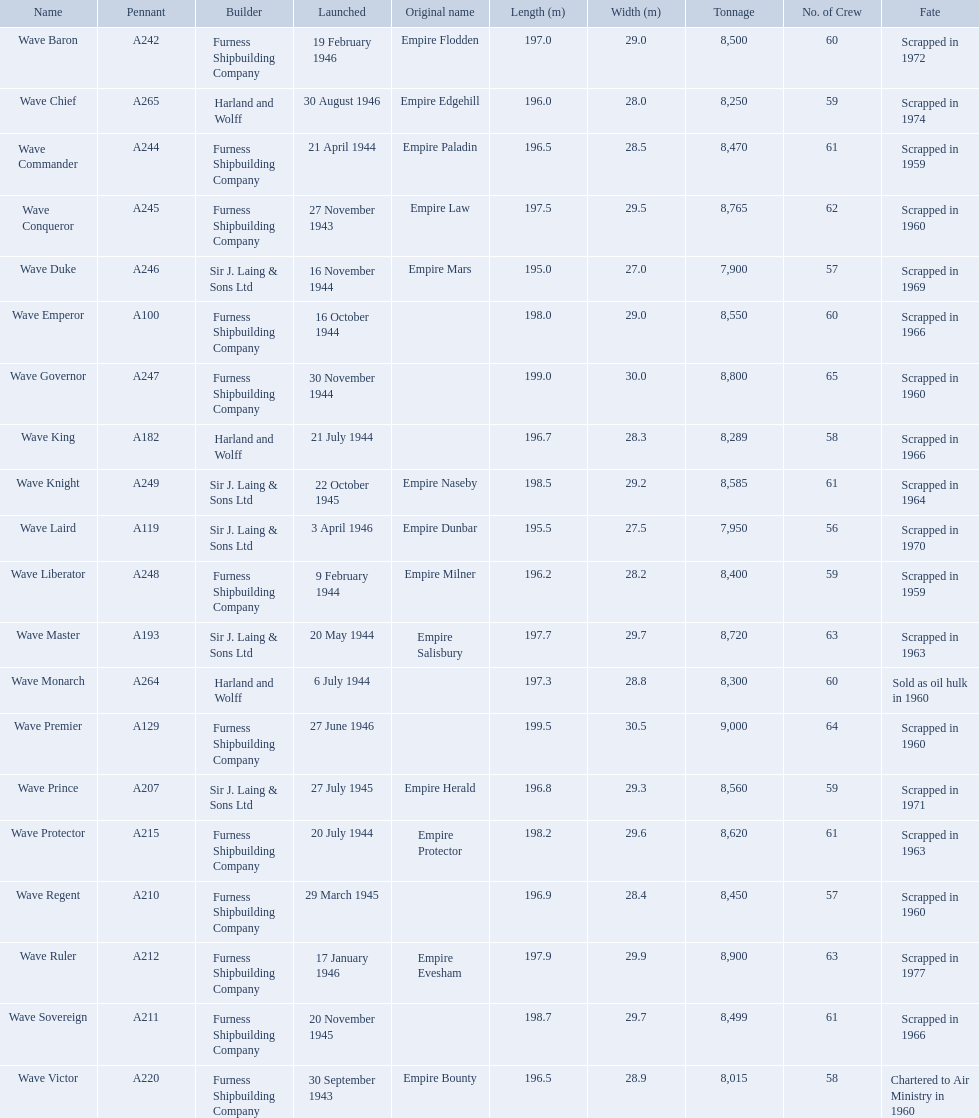What date was the wave victor launched? 30 September 1943. Would you be able to parse every entry in this table? {'header': ['Name', 'Pennant', 'Builder', 'Launched', 'Original name', 'Length (m)', 'Width (m)', 'Tonnage', 'No. of Crew', 'Fate'], 'rows': [['Wave Baron', 'A242', 'Furness Shipbuilding Company', '19 February 1946', 'Empire Flodden', '197.0', '29.0', '8,500', '60', 'Scrapped in 1972'], ['Wave Chief', 'A265', 'Harland and Wolff', '30 August 1946', 'Empire Edgehill', '196.0', '28.0', '8,250', '59', 'Scrapped in 1974'], ['Wave Commander', 'A244', 'Furness Shipbuilding Company', '21 April 1944', 'Empire Paladin', '196.5', '28.5', '8,470', '61', 'Scrapped in 1959'], ['Wave Conqueror', 'A245', 'Furness Shipbuilding Company', '27 November 1943', 'Empire Law', '197.5', '29.5', '8,765', '62', 'Scrapped in 1960'], ['Wave Duke', 'A246', 'Sir J. Laing & Sons Ltd', '16 November 1944', 'Empire Mars', '195.0', '27.0', '7,900', '57', 'Scrapped in 1969'], ['Wave Emperor', 'A100', 'Furness Shipbuilding Company', '16 October 1944', '', '198.0', '29.0', '8,550', '60', 'Scrapped in 1966'], ['Wave Governor', 'A247', 'Furness Shipbuilding Company', '30 November 1944', '', '199.0', '30.0', '8,800', '65', 'Scrapped in 1960'], ['Wave King', 'A182', 'Harland and Wolff', '21 July 1944', '', '196.7', '28.3', '8,289', '58', 'Scrapped in 1966'], ['Wave Knight', 'A249', 'Sir J. Laing & Sons Ltd', '22 October 1945', 'Empire Naseby', '198.5', '29.2', '8,585', '61', 'Scrapped in 1964'], ['Wave Laird', 'A119', 'Sir J. Laing & Sons Ltd', '3 April 1946', 'Empire Dunbar', '195.5', '27.5', '7,950', '56', 'Scrapped in 1970'], ['Wave Liberator', 'A248', 'Furness Shipbuilding Company', '9 February 1944', 'Empire Milner', '196.2', '28.2', '8,400', '59', 'Scrapped in 1959'], ['Wave Master', 'A193', 'Sir J. Laing & Sons Ltd', '20 May 1944', 'Empire Salisbury', '197.7', '29.7', '8,720', '63', 'Scrapped in 1963'], ['Wave Monarch', 'A264', 'Harland and Wolff', '6 July 1944', '', '197.3', '28.8', '8,300', '60', 'Sold as oil hulk in 1960'], ['Wave Premier', 'A129', 'Furness Shipbuilding Company', '27 June 1946', '', '199.5', '30.5', '9,000', '64', 'Scrapped in 1960'], ['Wave Prince', 'A207', 'Sir J. Laing & Sons Ltd', '27 July 1945', 'Empire Herald', '196.8', '29.3', '8,560', '59', 'Scrapped in 1971'], ['Wave Protector', 'A215', 'Furness Shipbuilding Company', '20 July 1944', 'Empire Protector', '198.2', '29.6', '8,620', '61', 'Scrapped in 1963'], ['Wave Regent', 'A210', 'Furness Shipbuilding Company', '29 March 1945', '', '196.9', '28.4', '8,450', '57', 'Scrapped in 1960'], ['Wave Ruler', 'A212', 'Furness Shipbuilding Company', '17 January 1946', 'Empire Evesham', '197.9', '29.9', '8,900', '63', 'Scrapped in 1977'], ['Wave Sovereign', 'A211', 'Furness Shipbuilding Company', '20 November 1945', '', '198.7', '29.7', '8,499', '61', 'Scrapped in 1966'], ['Wave Victor', 'A220', 'Furness Shipbuilding Company', '30 September 1943', 'Empire Bounty', '196.5', '28.9', '8,015', '58', 'Chartered to Air Ministry in 1960']]} What other oiler was launched that same year? Wave Conqueror. 